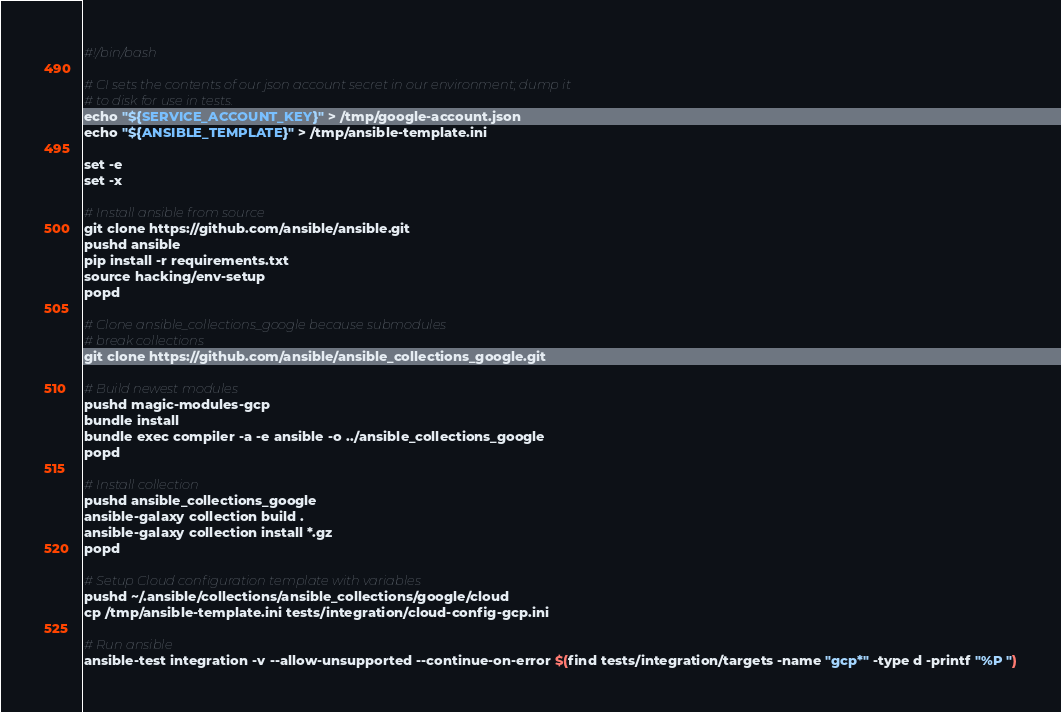Convert code to text. <code><loc_0><loc_0><loc_500><loc_500><_Bash_>#!/bin/bash

# CI sets the contents of our json account secret in our environment; dump it
# to disk for use in tests.
echo "${SERVICE_ACCOUNT_KEY}" > /tmp/google-account.json
echo "${ANSIBLE_TEMPLATE}" > /tmp/ansible-template.ini

set -e
set -x

# Install ansible from source
git clone https://github.com/ansible/ansible.git
pushd ansible
pip install -r requirements.txt
source hacking/env-setup
popd

# Clone ansible_collections_google because submodules
# break collections
git clone https://github.com/ansible/ansible_collections_google.git

# Build newest modules
pushd magic-modules-gcp
bundle install
bundle exec compiler -a -e ansible -o ../ansible_collections_google
popd

# Install collection
pushd ansible_collections_google
ansible-galaxy collection build .
ansible-galaxy collection install *.gz
popd

# Setup Cloud configuration template with variables
pushd ~/.ansible/collections/ansible_collections/google/cloud
cp /tmp/ansible-template.ini tests/integration/cloud-config-gcp.ini

# Run ansible
ansible-test integration -v --allow-unsupported --continue-on-error $(find tests/integration/targets -name "gcp*" -type d -printf "%P ")
</code> 